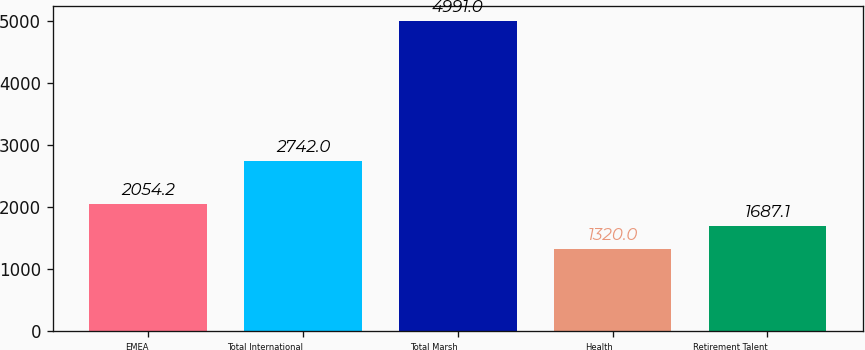Convert chart. <chart><loc_0><loc_0><loc_500><loc_500><bar_chart><fcel>EMEA<fcel>Total International<fcel>Total Marsh<fcel>Health<fcel>Retirement Talent<nl><fcel>2054.2<fcel>2742<fcel>4991<fcel>1320<fcel>1687.1<nl></chart> 